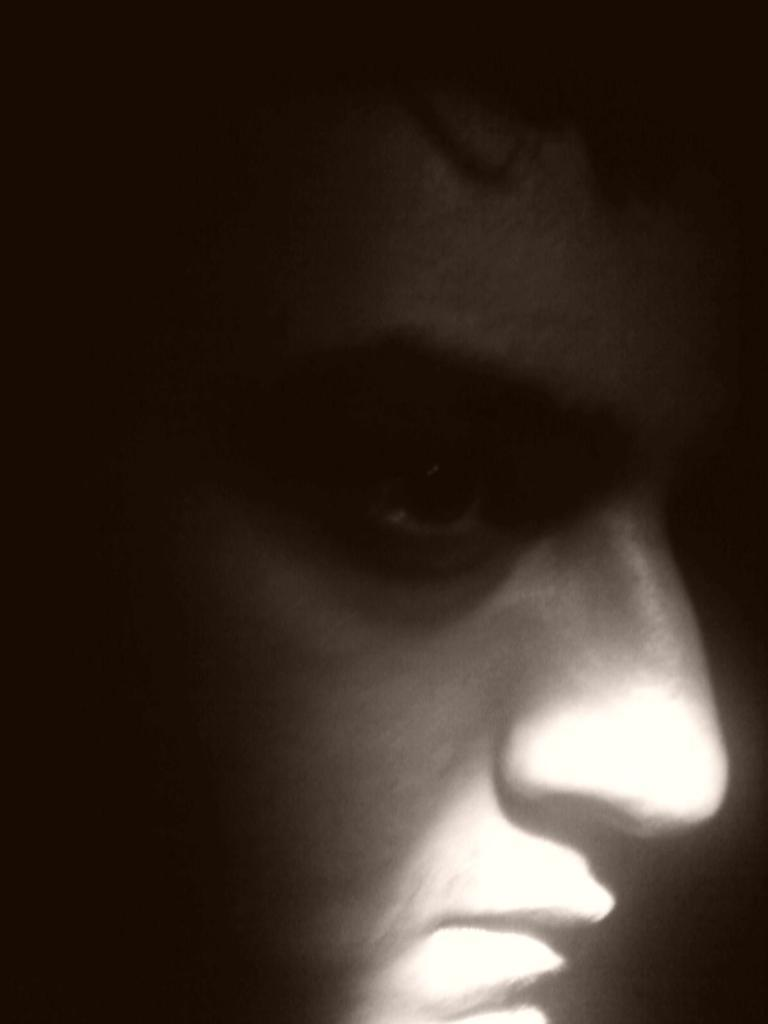What is the main subject of the image? There is a person in the image. What can be observed about the background of the image? The background of the image is dark. How would you describe the color scheme of the image? The image is in black and white. What type of property does the person own in the image? There is no information about property ownership in the image, as it only features a person in a dark, black and white background. 